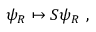Convert formula to latex. <formula><loc_0><loc_0><loc_500><loc_500>\psi _ { R } \mapsto S \psi _ { R } ,</formula> 